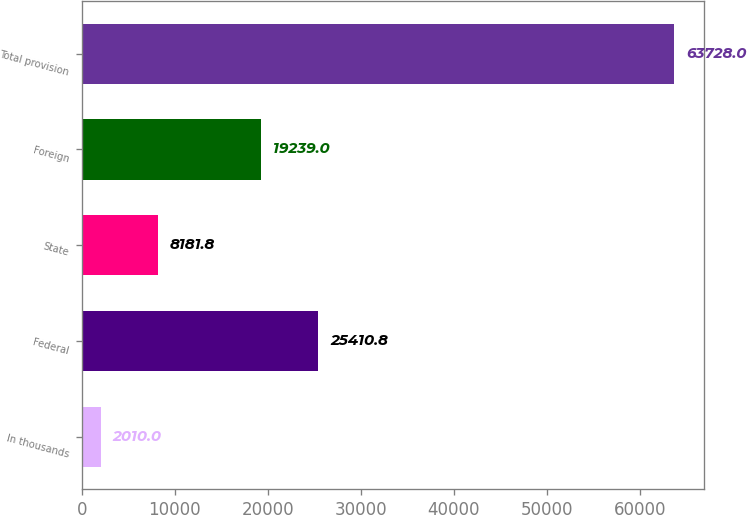Convert chart. <chart><loc_0><loc_0><loc_500><loc_500><bar_chart><fcel>In thousands<fcel>Federal<fcel>State<fcel>Foreign<fcel>Total provision<nl><fcel>2010<fcel>25410.8<fcel>8181.8<fcel>19239<fcel>63728<nl></chart> 